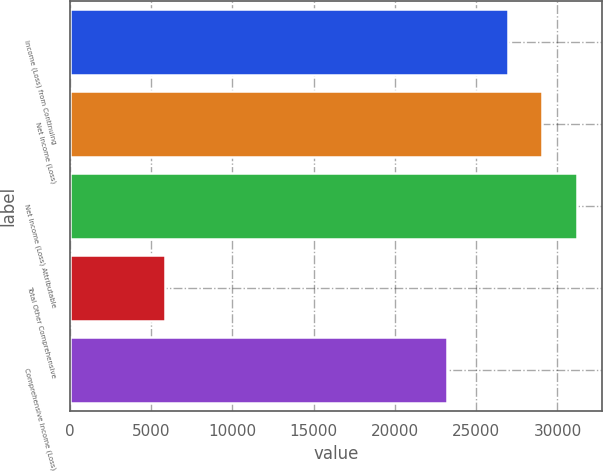<chart> <loc_0><loc_0><loc_500><loc_500><bar_chart><fcel>Income (Loss) from Continuing<fcel>Net Income (Loss)<fcel>Net Income (Loss) Attributable<fcel>Total Other Comprehensive<fcel>Comprehensive Income (Loss)<nl><fcel>26960<fcel>29070.8<fcel>31181.6<fcel>5852<fcel>23218.8<nl></chart> 